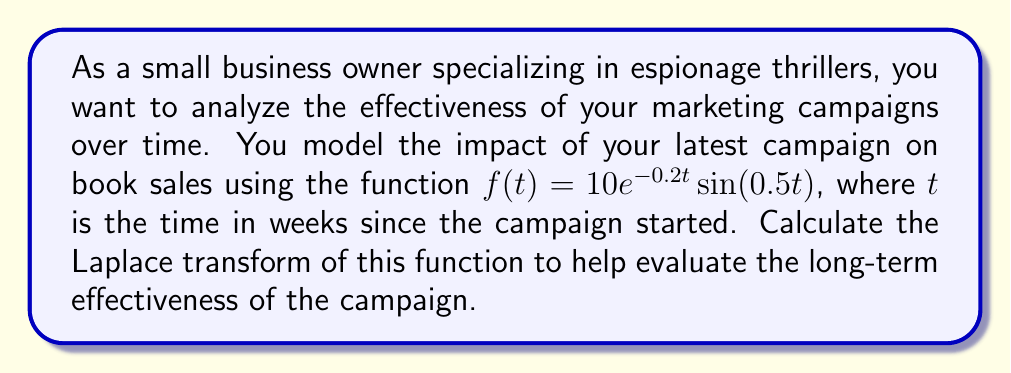Teach me how to tackle this problem. To solve this problem, we'll use the Laplace transform of the given function. Let's break it down step-by-step:

1) The Laplace transform of $f(t)$ is defined as:

   $$F(s) = \mathcal{L}\{f(t)\} = \int_0^\infty f(t)e^{-st}dt$$

2) In our case, $f(t) = 10e^{-0.2t}\sin(0.5t)$. We need to find:

   $$F(s) = 10\int_0^\infty e^{-0.2t}\sin(0.5t)e^{-st}dt$$

3) This can be rewritten as:

   $$F(s) = 10\int_0^\infty e^{-(s+0.2)t}\sin(0.5t)dt$$

4) We can use the Laplace transform formula for $e^{at}\sin(bt)$:

   $$\mathcal{L}\{e^{at}\sin(bt)\} = \frac{b}{(s-a)^2 + b^2}$$

5) In our case, $a = -0.2$ and $b = 0.5$. Substituting these values:

   $$F(s) = 10 \cdot \frac{0.5}{(s-(-0.2))^2 + 0.5^2}$$

6) Simplifying:

   $$F(s) = \frac{5}{(s+0.2)^2 + 0.25}$$

This is the Laplace transform of our marketing impact function. It allows us to analyze the long-term behavior of the campaign's effectiveness without solving complex differential equations.
Answer: $$F(s) = \frac{5}{(s+0.2)^2 + 0.25}$$ 